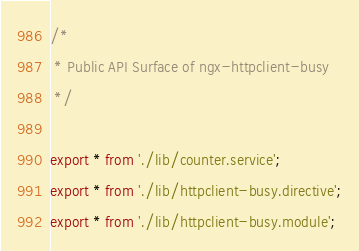Convert code to text. <code><loc_0><loc_0><loc_500><loc_500><_TypeScript_>/*
 * Public API Surface of ngx-httpclient-busy
 */

export * from './lib/counter.service';
export * from './lib/httpclient-busy.directive';
export * from './lib/httpclient-busy.module';
</code> 